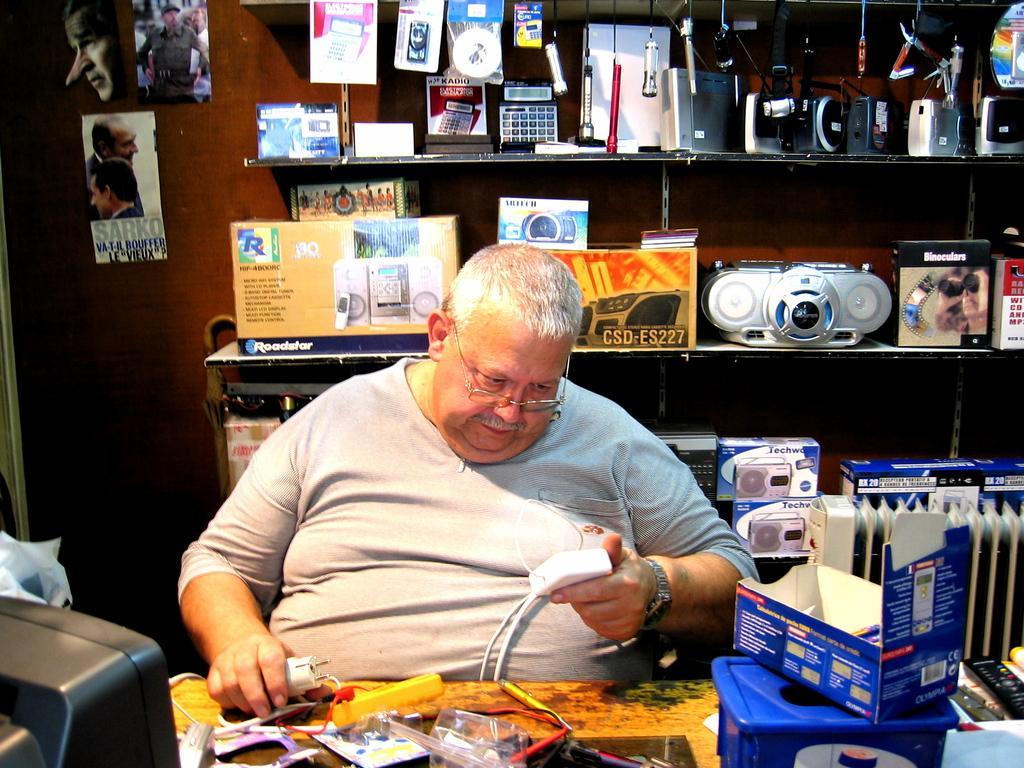Please provide a concise description of this image. In this image there is a table on that table there are electrical items, behind the table a man sitting in his hand there is a electrical device, in the background there is a wall to that wall there is a shelf on that shelf there are electrical items. 